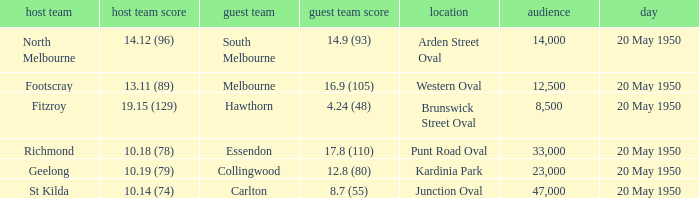What was the venue when the away team scored 14.9 (93)? Arden Street Oval. 